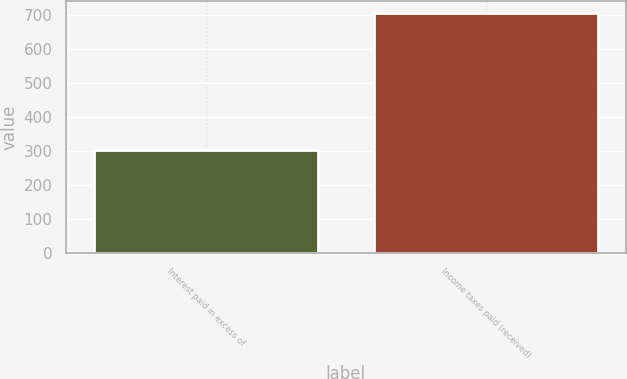Convert chart to OTSL. <chart><loc_0><loc_0><loc_500><loc_500><bar_chart><fcel>Interest paid in excess of<fcel>Income taxes paid (received)<nl><fcel>302<fcel>705<nl></chart> 